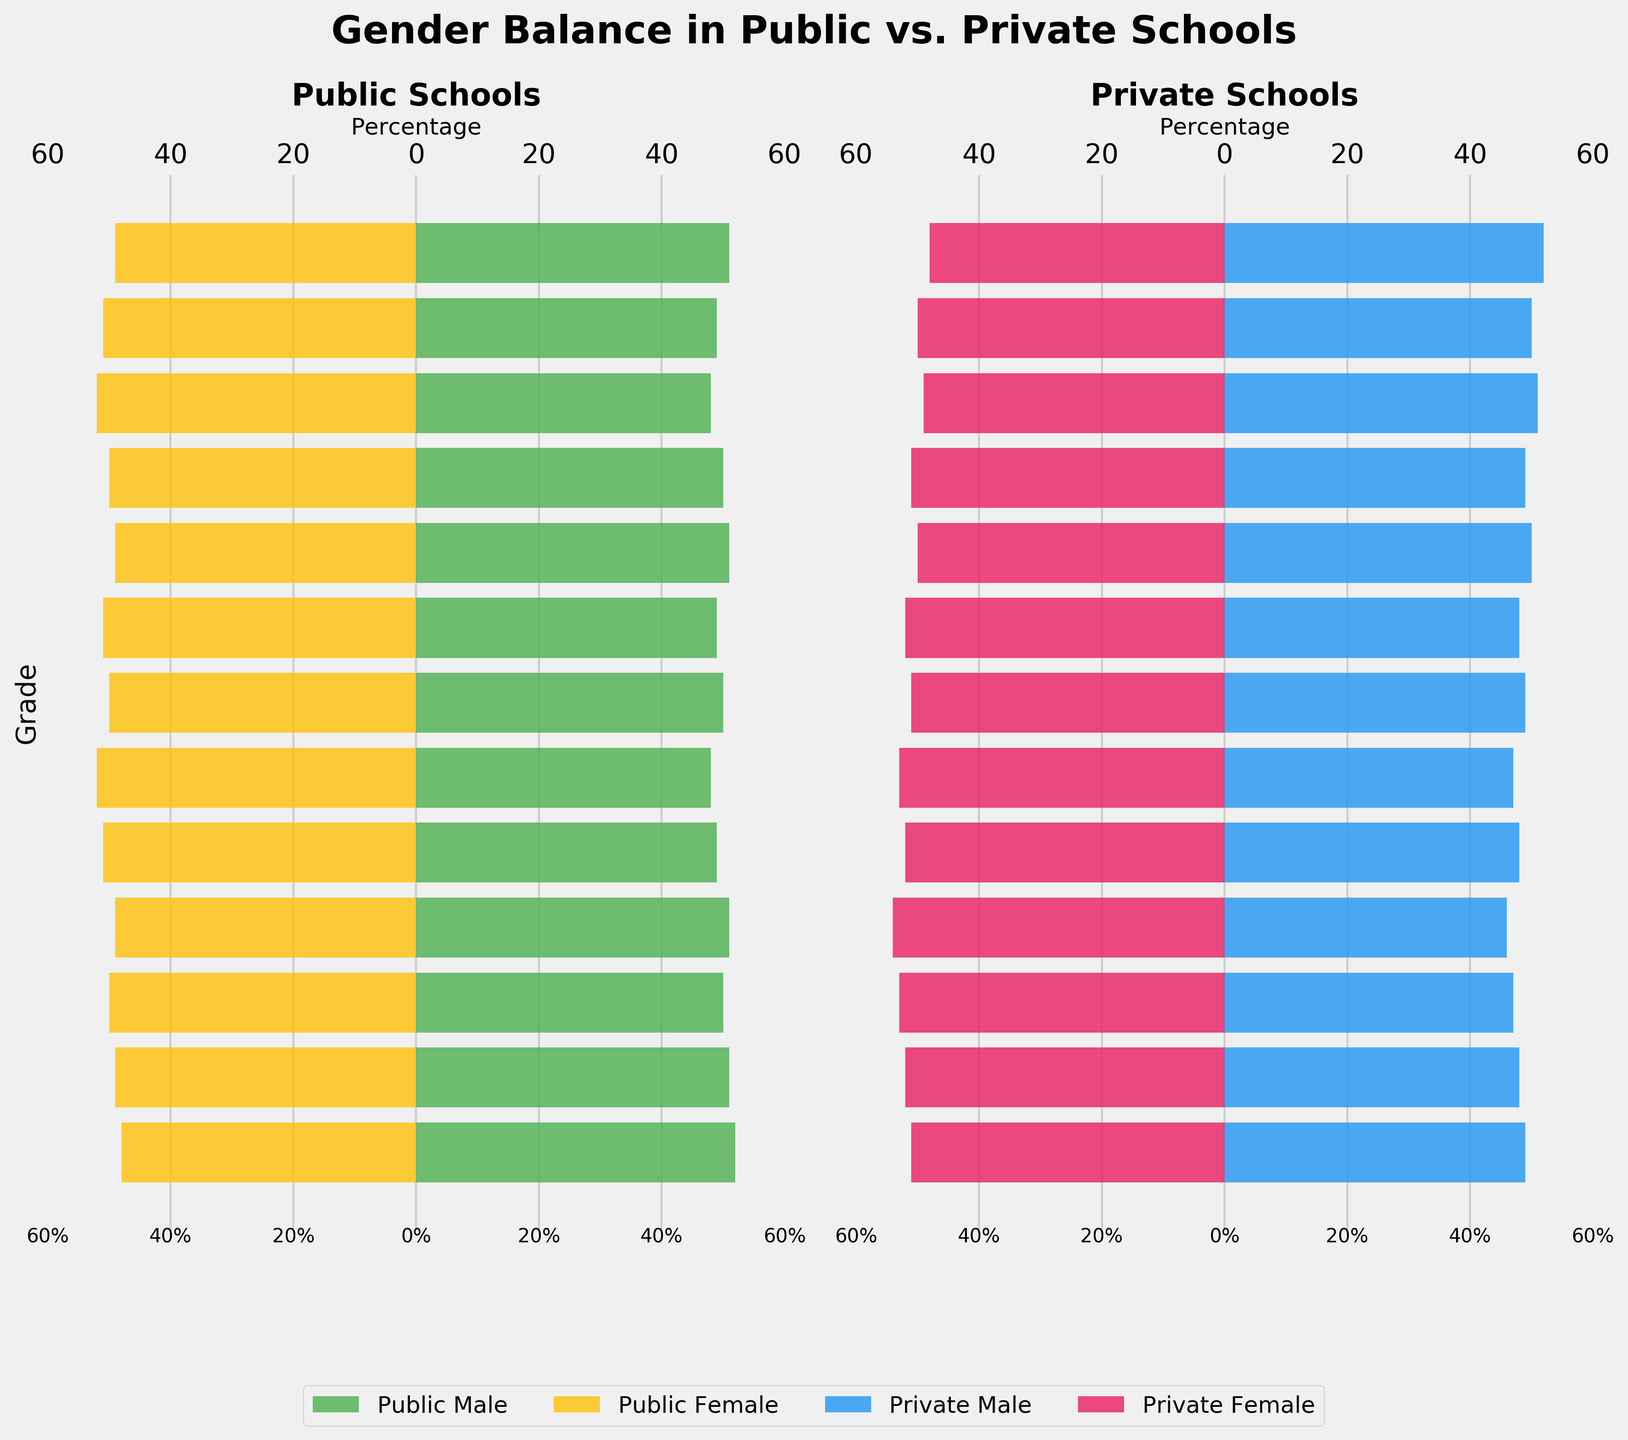What's the title of the figure? Look at the top center of the figure where the title is usually placed. This figure's title is written in a large, bold font.
Answer: Gender Balance in Public vs. Private Schools What's the percentage of male students in public high school (12th grade)? Refer to the left half of the figure under "Public Schools" and look for the bar corresponding to 12th grade on the y-axis. The bar extends to the right indicating around 52%.
Answer: 52% Which school type has a higher percentage of female students in 9th grade? Compare the bars for female students in 9th grade. In "Public Schools," the bar length for females is 49%, and in "Private Schools," it is 54%.
Answer: Private Schools What is the percentage difference between male students in private 6th grade and private 5th grade? Find the bars for male students in private 6th grade (49%) and private 5th grade (48%). Subtract the smaller percentage from the larger one: \(49% - 48% = 1%\).
Answer: 1% Does 1st grade have an equal percentage of male and female students in both public and private schools? Look at the bars for 1st grade in both public and private sections. Both genders have equal length bars meaning 49% male, 51% female in public and 50% each in private.
Answer: Yes Between 3rd and 2nd grades in private schools, which has more female students? Find the bars for female students in private 3rd grade (51%) and private 2nd grade (49%), and compare their values.
Answer: 3rd grade Which grade shows the most balanced gender distribution in public schools? Identify the grades where the male and female bars are nearly equal for public schools. The 10th and 6th grades show the most balanced distribution (both at 50%).
Answer: 10th and 6th grades If you consider only 7th grade, which school type has a closer to equal gender distribution? Check the bars for 7th grade in both public schools (48% male, 52% female) and private schools (47% male, 53% female). Subtract to see the balances: 4% vs. 6%. Public schools are closer.
Answer: Public Schools What is the total percentage of male students in public and private 8th grade combined? Add the percentages of male students from both public (49%) and private (48%) 8th grade: \(49% + 48% = 97%\).
Answer: 97% Is there any grade level in private schools where there are more male students than female students? Check the private school section for bars where male (blue) exceeds female (red). Only Kindergarten shows more males (52% male, 48% female).
Answer: Kindergarten 